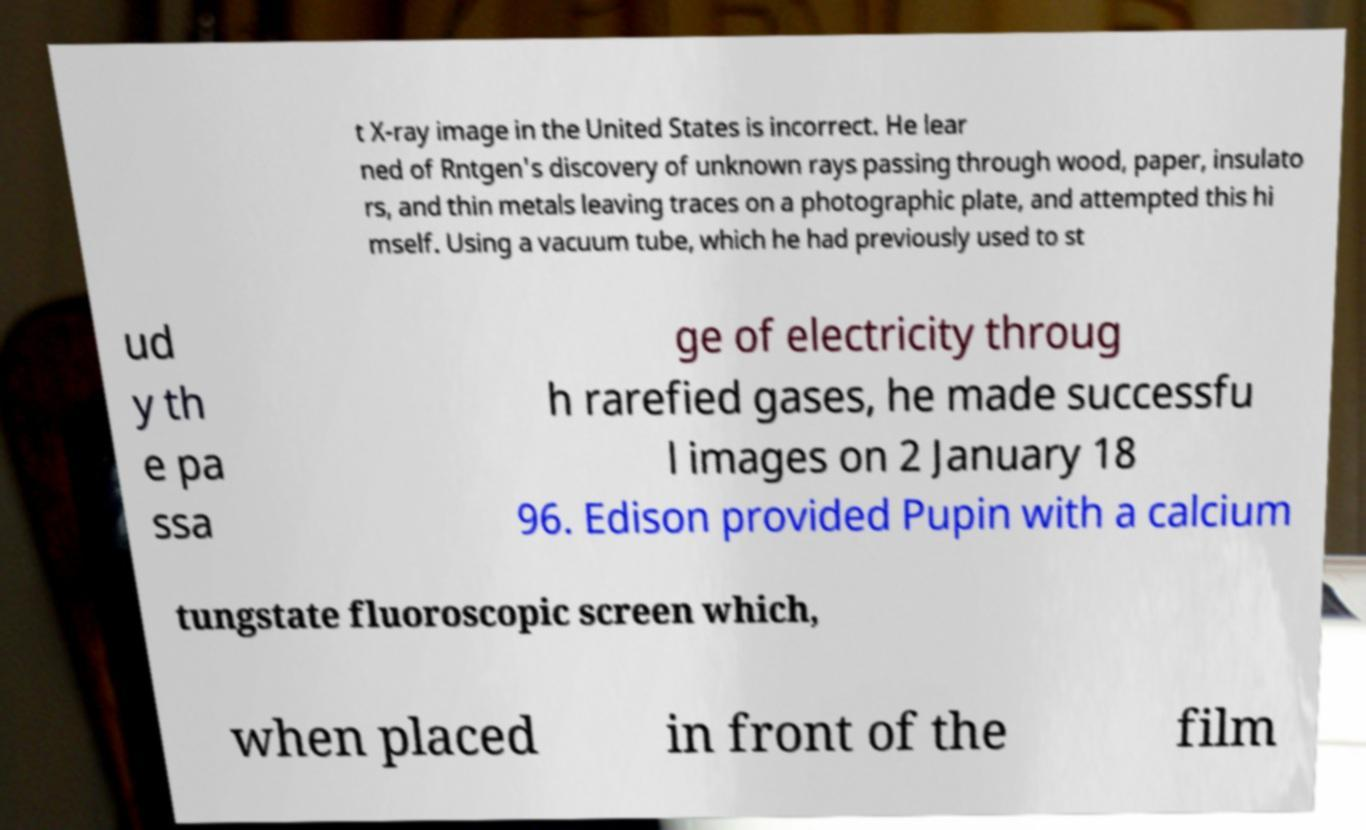Please identify and transcribe the text found in this image. t X-ray image in the United States is incorrect. He lear ned of Rntgen's discovery of unknown rays passing through wood, paper, insulato rs, and thin metals leaving traces on a photographic plate, and attempted this hi mself. Using a vacuum tube, which he had previously used to st ud y th e pa ssa ge of electricity throug h rarefied gases, he made successfu l images on 2 January 18 96. Edison provided Pupin with a calcium tungstate fluoroscopic screen which, when placed in front of the film 